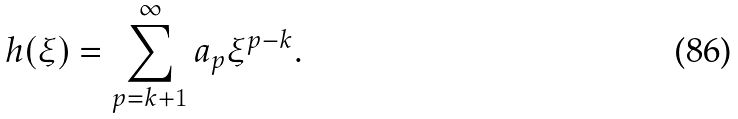<formula> <loc_0><loc_0><loc_500><loc_500>h ( \xi ) = \sum _ { p = k + 1 } ^ { \infty } a _ { p } \xi ^ { p - k } .</formula> 